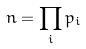<formula> <loc_0><loc_0><loc_500><loc_500>n = \prod _ { i } p _ { i }</formula> 